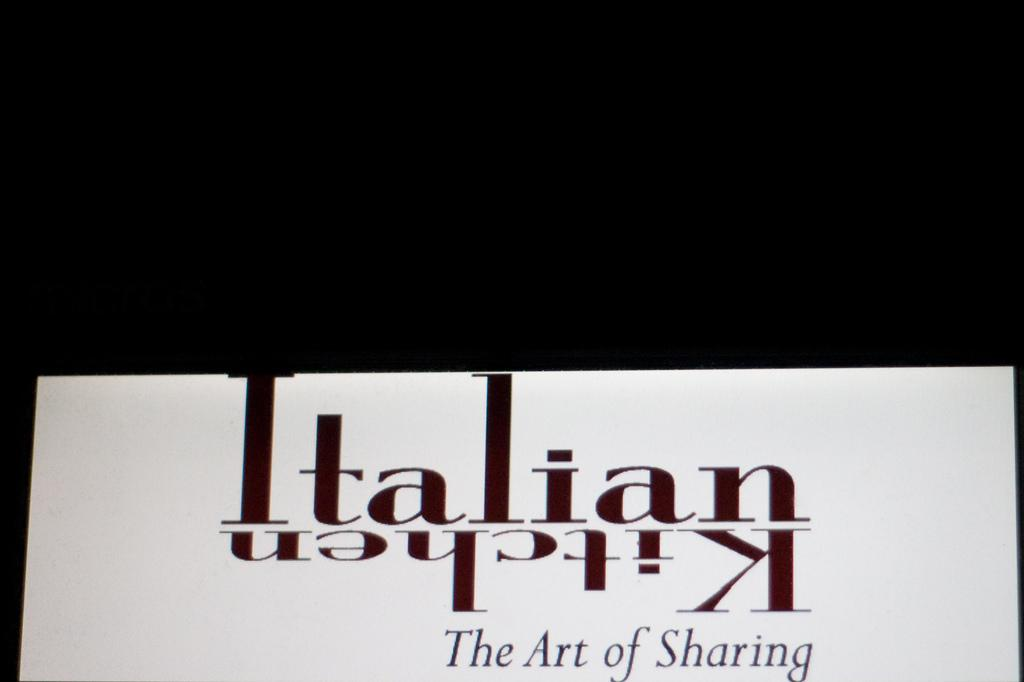Provide a one-sentence caption for the provided image. Italian kitchen the art of sharing book by itself. 